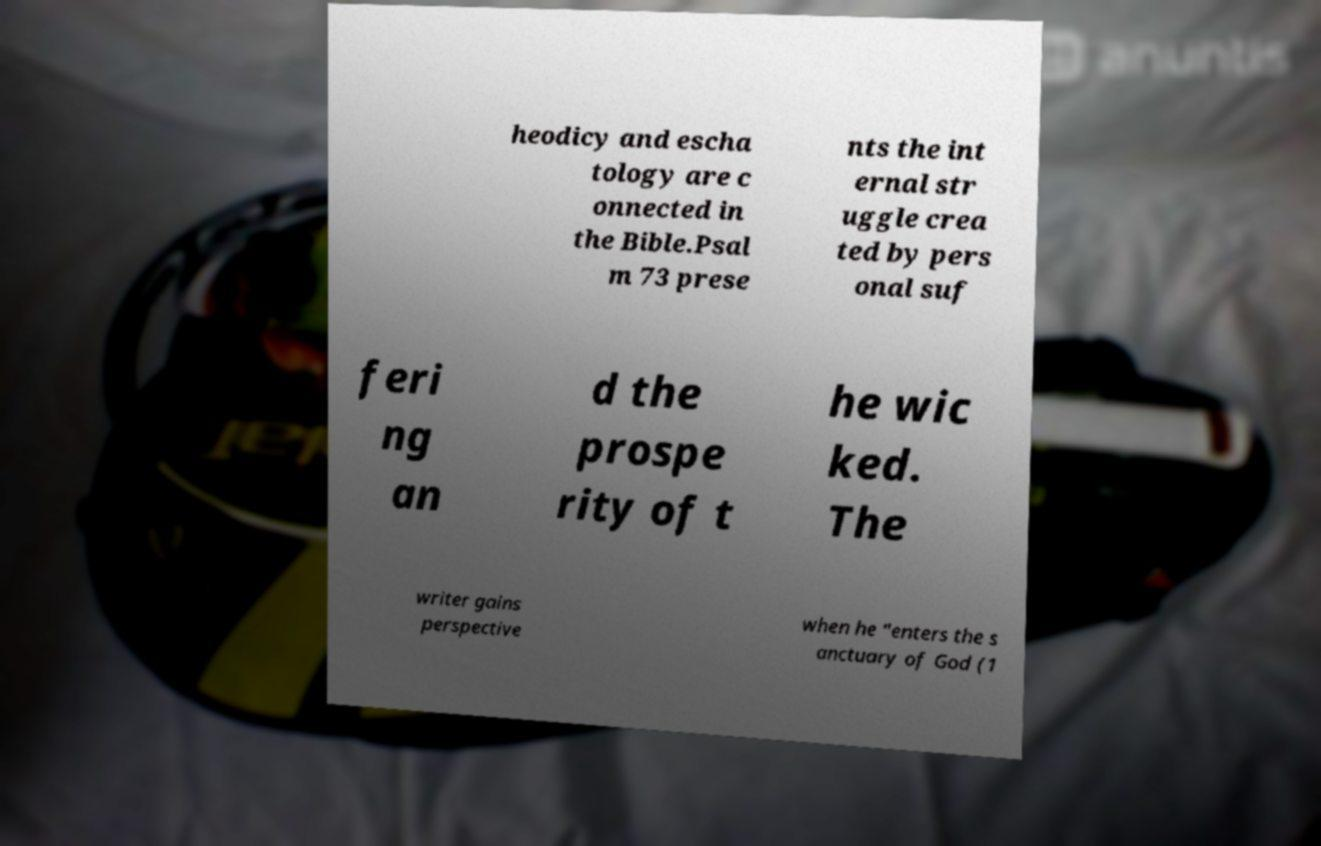Could you assist in decoding the text presented in this image and type it out clearly? heodicy and escha tology are c onnected in the Bible.Psal m 73 prese nts the int ernal str uggle crea ted by pers onal suf feri ng an d the prospe rity of t he wic ked. The writer gains perspective when he "enters the s anctuary of God (1 